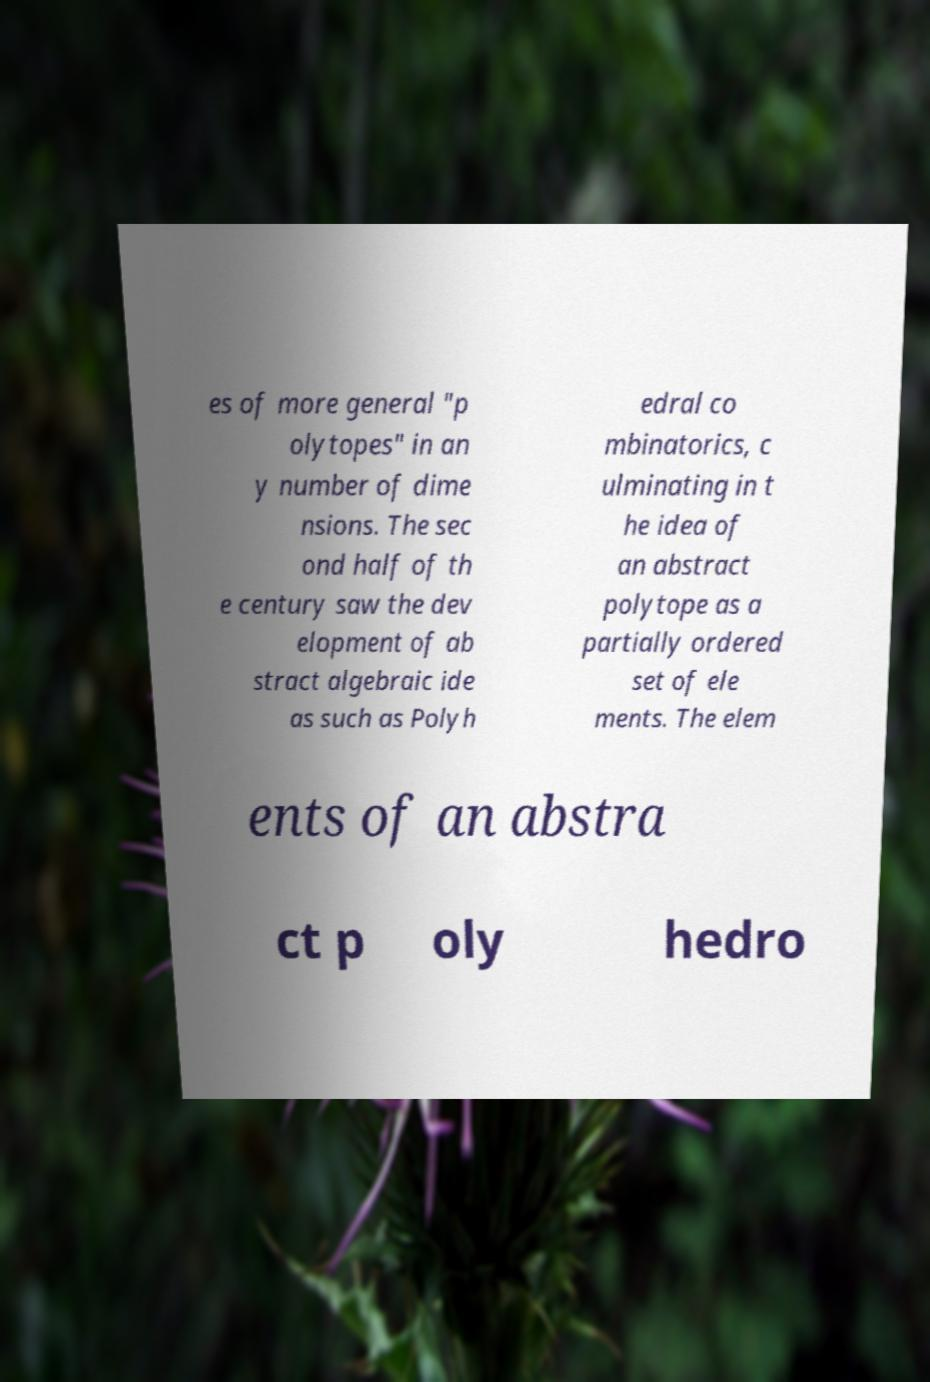Please identify and transcribe the text found in this image. es of more general "p olytopes" in an y number of dime nsions. The sec ond half of th e century saw the dev elopment of ab stract algebraic ide as such as Polyh edral co mbinatorics, c ulminating in t he idea of an abstract polytope as a partially ordered set of ele ments. The elem ents of an abstra ct p oly hedro 